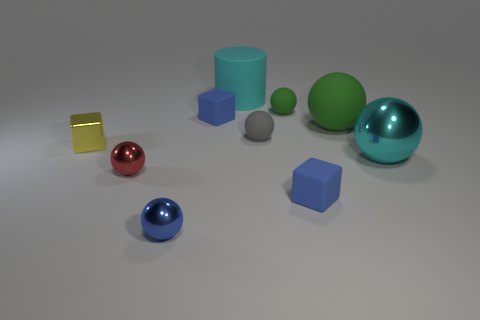Subtract all gray spheres. How many spheres are left? 5 Subtract all green matte balls. How many balls are left? 4 Subtract all yellow spheres. Subtract all purple cubes. How many spheres are left? 6 Subtract all balls. How many objects are left? 4 Add 2 small balls. How many small balls are left? 6 Add 5 tiny yellow blocks. How many tiny yellow blocks exist? 6 Subtract 0 gray cylinders. How many objects are left? 10 Subtract all small blue matte blocks. Subtract all cyan balls. How many objects are left? 7 